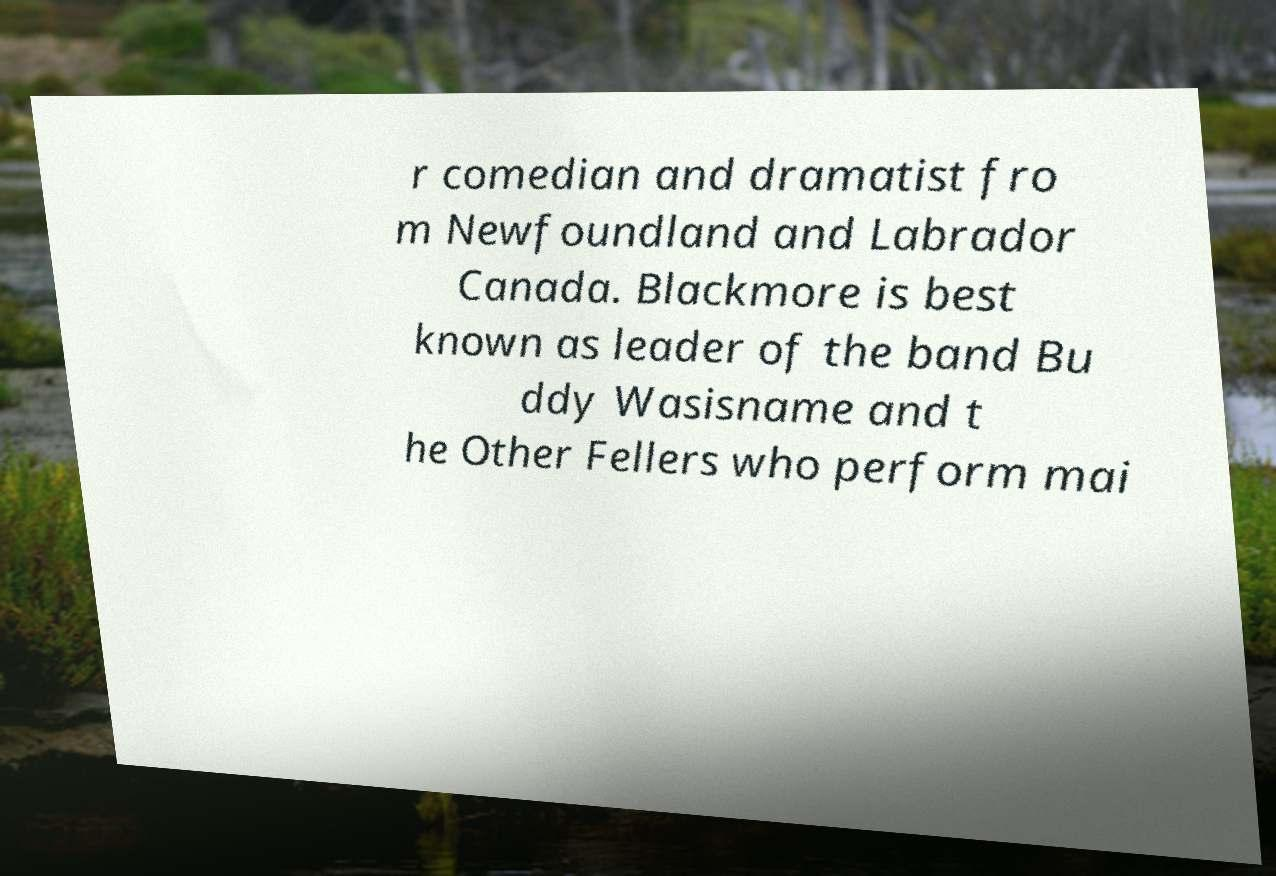Can you accurately transcribe the text from the provided image for me? r comedian and dramatist fro m Newfoundland and Labrador Canada. Blackmore is best known as leader of the band Bu ddy Wasisname and t he Other Fellers who perform mai 